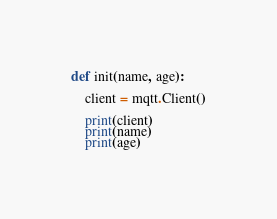Convert code to text. <code><loc_0><loc_0><loc_500><loc_500><_Python_>def init(name, age):

    client = mqtt.Client()

    print(client)
    print(name)
    print(age)
</code> 